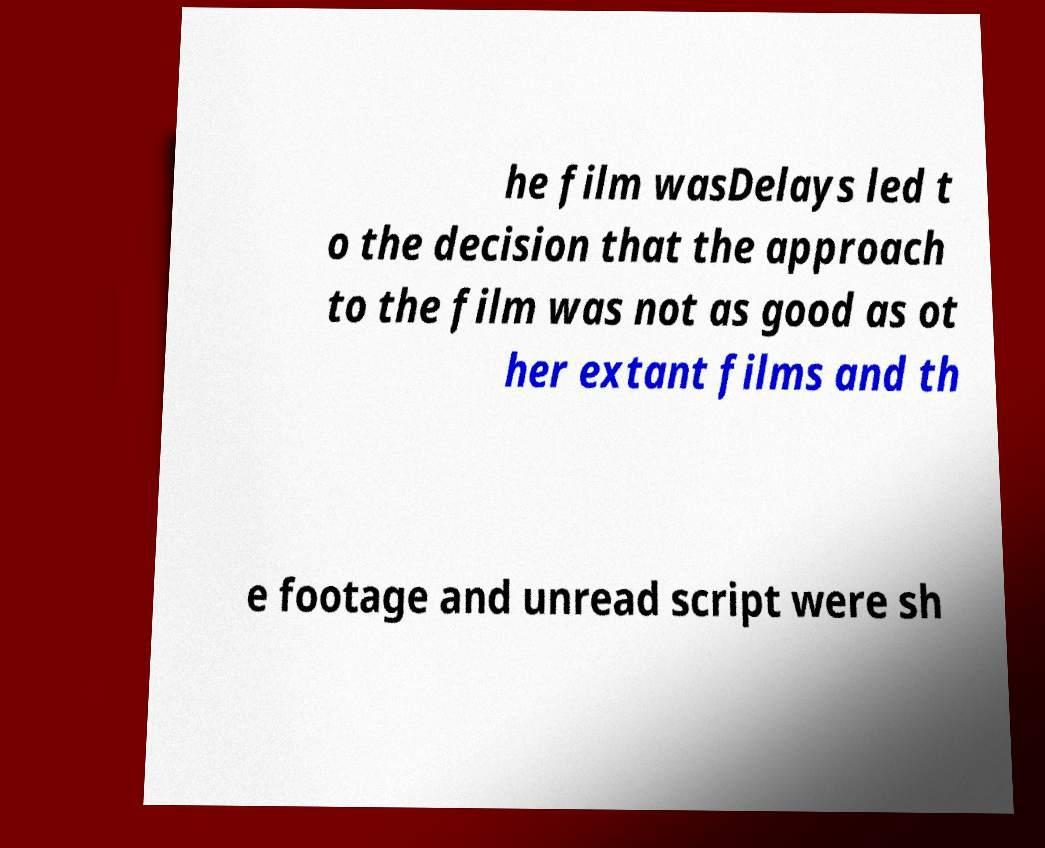For documentation purposes, I need the text within this image transcribed. Could you provide that? he film wasDelays led t o the decision that the approach to the film was not as good as ot her extant films and th e footage and unread script were sh 